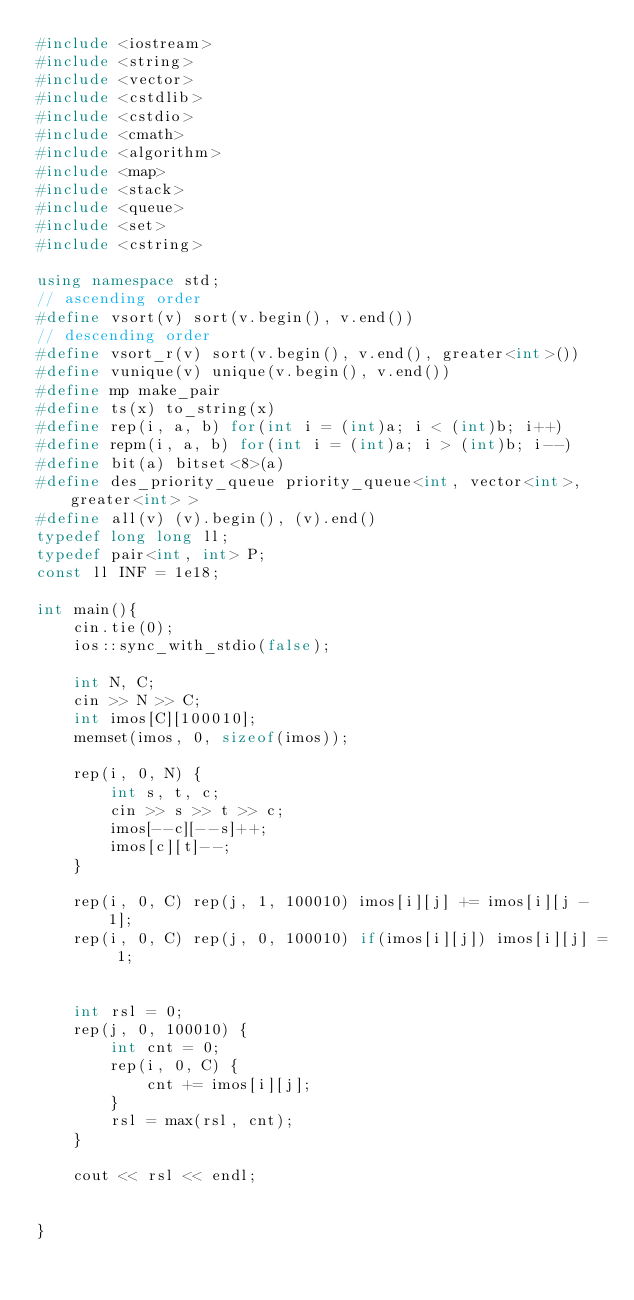Convert code to text. <code><loc_0><loc_0><loc_500><loc_500><_C++_>#include <iostream>
#include <string>
#include <vector>
#include <cstdlib>
#include <cstdio>
#include <cmath>
#include <algorithm>
#include <map>
#include <stack>
#include <queue>
#include <set>
#include <cstring>

using namespace std;
// ascending order
#define vsort(v) sort(v.begin(), v.end())
// descending order
#define vsort_r(v) sort(v.begin(), v.end(), greater<int>())
#define vunique(v) unique(v.begin(), v.end())
#define mp make_pair
#define ts(x) to_string(x)
#define rep(i, a, b) for(int i = (int)a; i < (int)b; i++)
#define repm(i, a, b) for(int i = (int)a; i > (int)b; i--)
#define bit(a) bitset<8>(a)
#define des_priority_queue priority_queue<int, vector<int>, greater<int> >
#define all(v) (v).begin(), (v).end()
typedef long long ll;
typedef pair<int, int> P;
const ll INF = 1e18;

int main(){
	cin.tie(0);
	ios::sync_with_stdio(false);

    int N, C;
    cin >> N >> C;
    int imos[C][100010];
    memset(imos, 0, sizeof(imos));

    rep(i, 0, N) {
        int s, t, c;
        cin >> s >> t >> c;
        imos[--c][--s]++;
        imos[c][t]--;
    }

    rep(i, 0, C) rep(j, 1, 100010) imos[i][j] += imos[i][j - 1];
    rep(i, 0, C) rep(j, 0, 100010) if(imos[i][j]) imos[i][j] = 1;


    int rsl = 0;
    rep(j, 0, 100010) {
        int cnt = 0;
        rep(i, 0, C) {
            cnt += imos[i][j];
        }
        rsl = max(rsl, cnt);
    }

    cout << rsl << endl;


}
</code> 